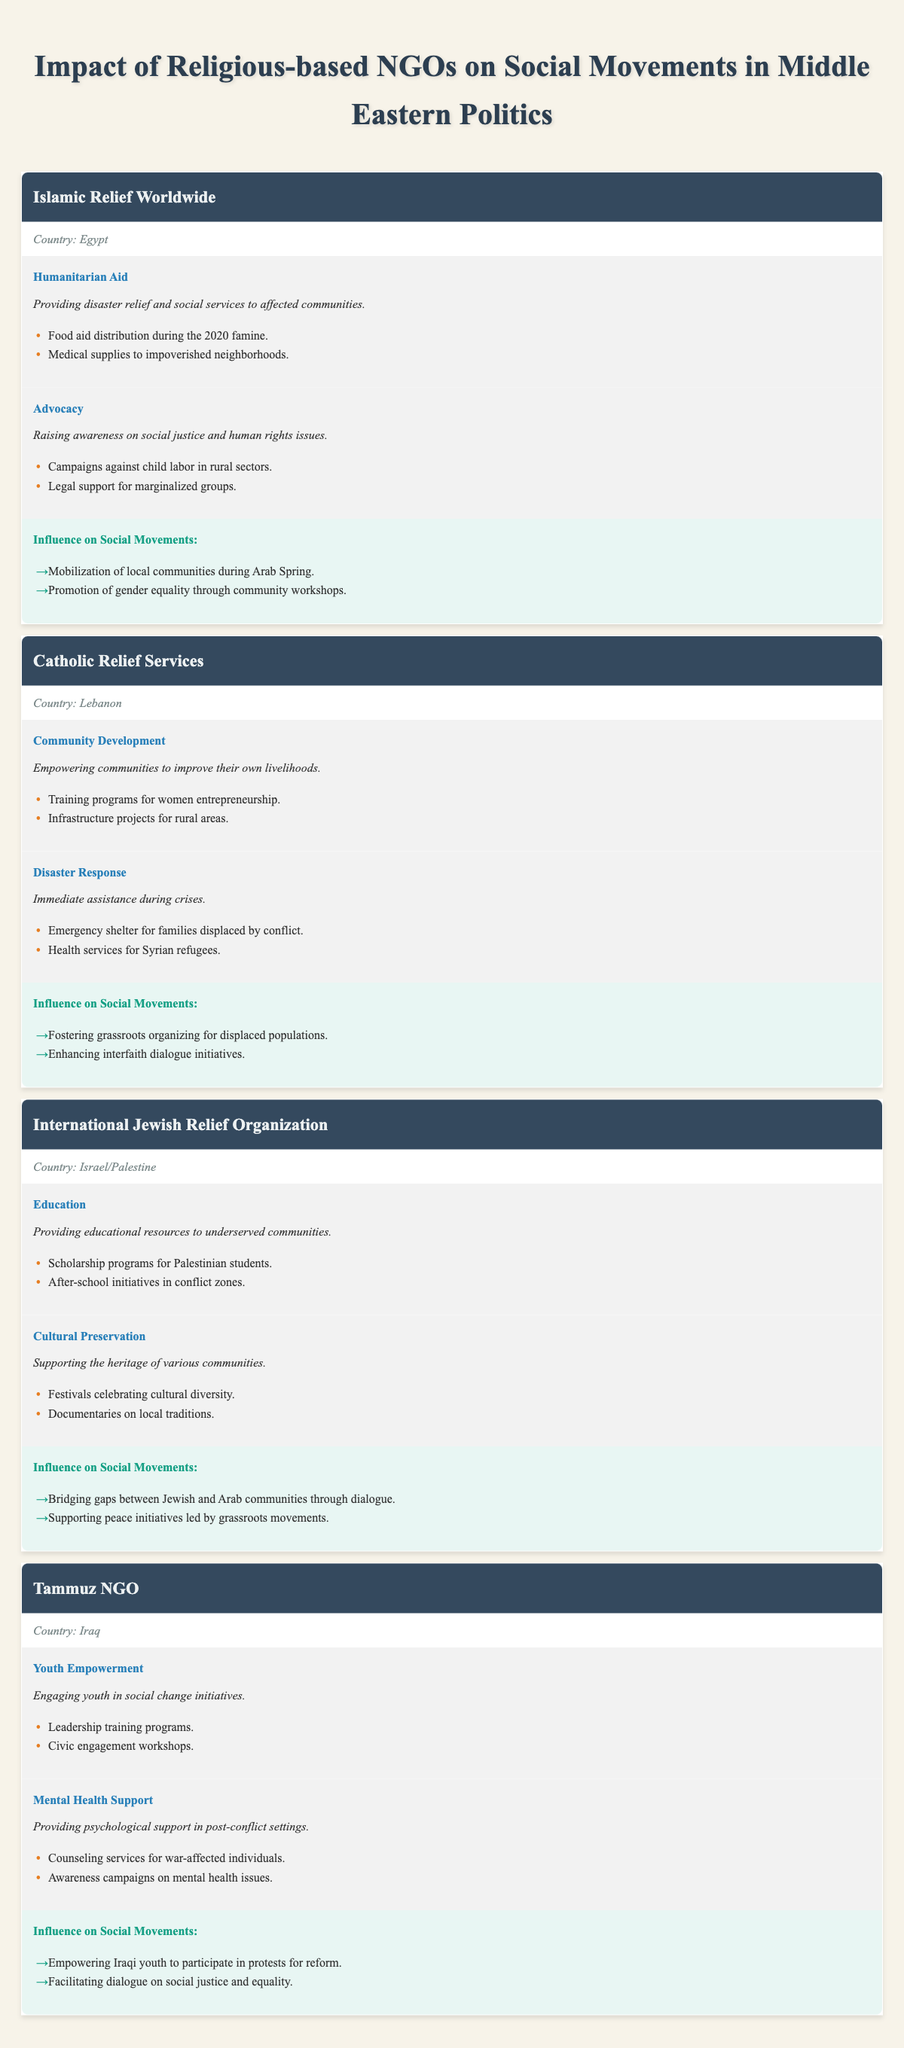What is the impact area for Islamic Relief Worldwide related to advocacy? According to the table, the advocacy impact area for Islamic Relief Worldwide is focused on raising awareness on social justice and human rights issues.
Answer: Advocacy Which NGO is involved in youth empowerment in Iraq? The table shows that Tammuz NGO is the one involved in youth empowerment, engaging youth in social change initiatives.
Answer: Tammuz NGO Does Catholic Relief Services provide disaster response in Lebanon? Yes, the table indicates that Catholic Relief Services does provide immediate assistance during crises, highlighting its role in disaster response.
Answer: Yes How many influence areas are listed for the International Jewish Relief Organization? The table lists two influence areas for the International Jewish Relief Organization: bridging gaps between communities and supporting grassroots peace initiatives. Thus, the total is two.
Answer: 2 What are the specific examples of humanitarian aid provided by Islamic Relief Worldwide? The table provides two examples of humanitarian aid by Islamic Relief Worldwide: food aid distribution during the 2020 famine and the provision of medical supplies to impoverished neighborhoods.
Answer: Food aid distribution during the 2020 famine, Medical supplies to impoverished neighborhoods How does Tammuz NGO influence social movements in Iraq? Tammuz NGO influences social movements by empowering Iraqi youth to participate in protests for reform and facilitating dialogue on social justice and equality.
Answer: Empowering youth, facilitating dialogue Is there any NGO that focuses on cultural preservation, and if so, which one? Yes, the International Jewish Relief Organization focuses on cultural preservation, supporting the heritage of various communities.
Answer: Yes, International Jewish Relief Organization What type of training programs does Catholic Relief Services offer for women? The table states that Catholic Relief Services offers training programs for women entrepreneurship as part of their community development impact area.
Answer: Training programs for women entrepreneurship Which NGO's influence includes enhancing interfaith dialogue initiatives? The influence of Catholic Relief Services includes enhancing interfaith dialogue initiatives as per the information listed in the table.
Answer: Catholic Relief Services 